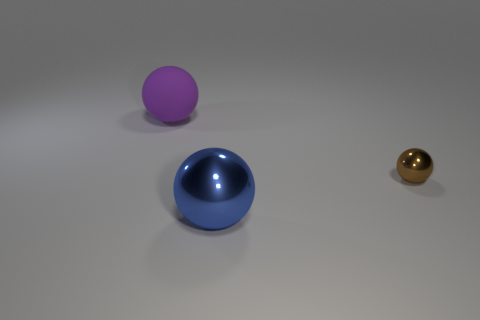What color is the big thing right of the big object that is behind the brown ball? blue 